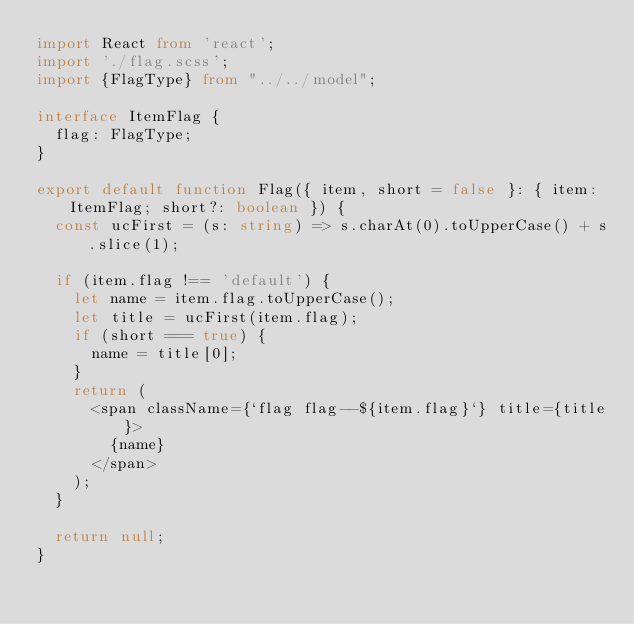<code> <loc_0><loc_0><loc_500><loc_500><_TypeScript_>import React from 'react';
import './flag.scss';
import {FlagType} from "../../model";

interface ItemFlag {
  flag: FlagType;
}

export default function Flag({ item, short = false }: { item: ItemFlag; short?: boolean }) {
  const ucFirst = (s: string) => s.charAt(0).toUpperCase() + s.slice(1);

  if (item.flag !== 'default') {
    let name = item.flag.toUpperCase();
    let title = ucFirst(item.flag);
    if (short === true) {
      name = title[0];
    }
    return (
      <span className={`flag flag--${item.flag}`} title={title}>
        {name}
      </span>
    );
  }

  return null;
}
</code> 